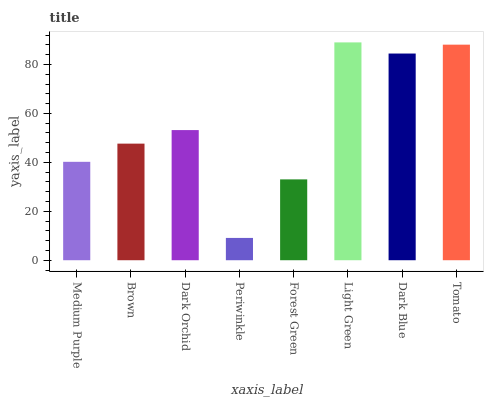Is Periwinkle the minimum?
Answer yes or no. Yes. Is Light Green the maximum?
Answer yes or no. Yes. Is Brown the minimum?
Answer yes or no. No. Is Brown the maximum?
Answer yes or no. No. Is Brown greater than Medium Purple?
Answer yes or no. Yes. Is Medium Purple less than Brown?
Answer yes or no. Yes. Is Medium Purple greater than Brown?
Answer yes or no. No. Is Brown less than Medium Purple?
Answer yes or no. No. Is Dark Orchid the high median?
Answer yes or no. Yes. Is Brown the low median?
Answer yes or no. Yes. Is Tomato the high median?
Answer yes or no. No. Is Tomato the low median?
Answer yes or no. No. 